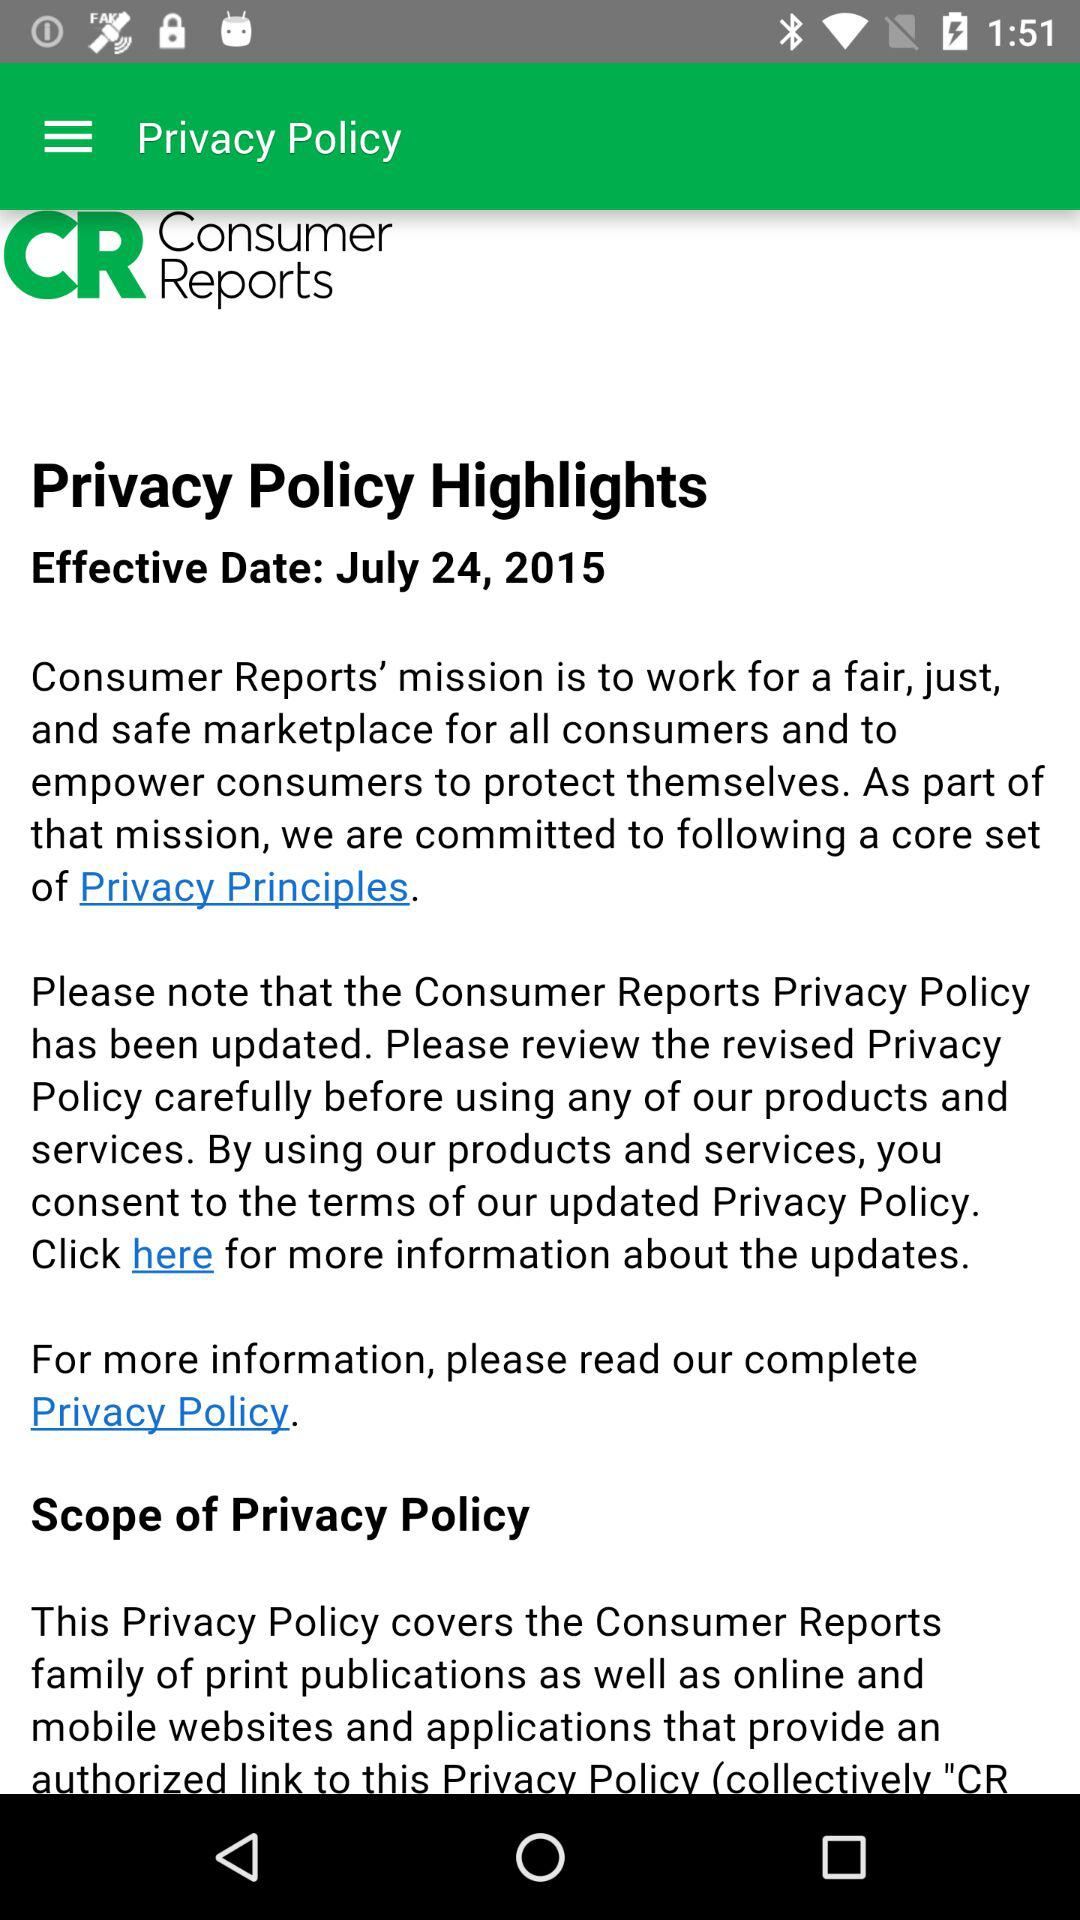What is the effective date of the privacy policy? The effective date is July 24, 2015. 